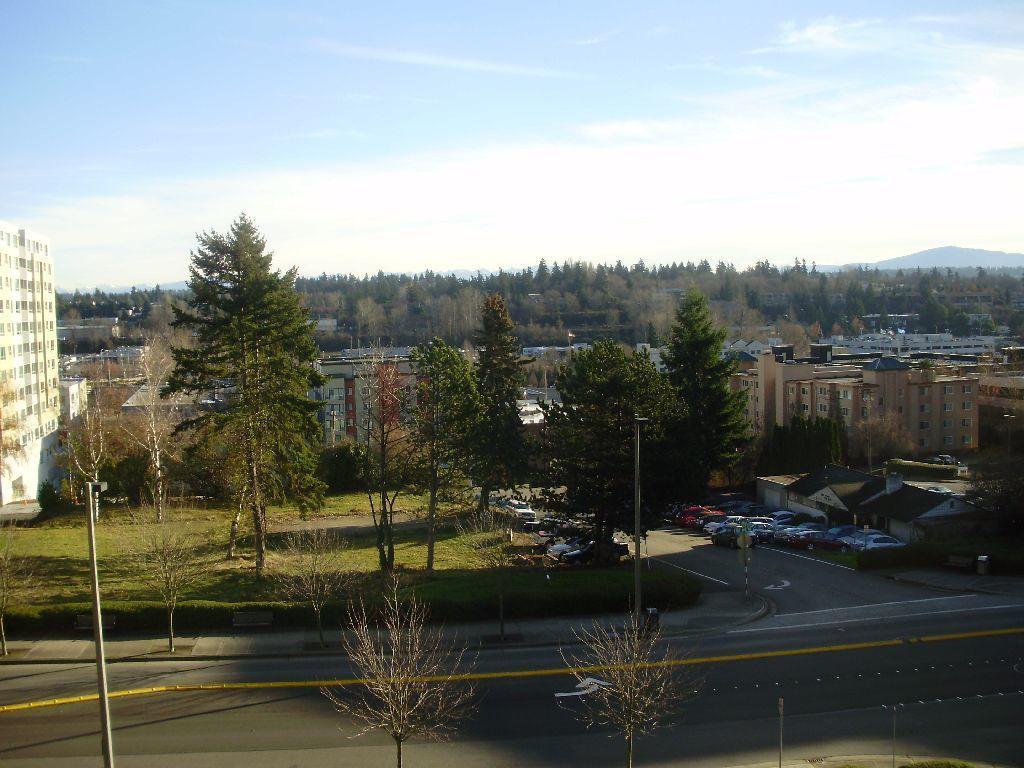How would you summarize this image in a sentence or two? In this image there are trees and buildings. At the bottom there is a road and we can see cars on the road. There are poles. In the background there are hills and we can see the sky. 